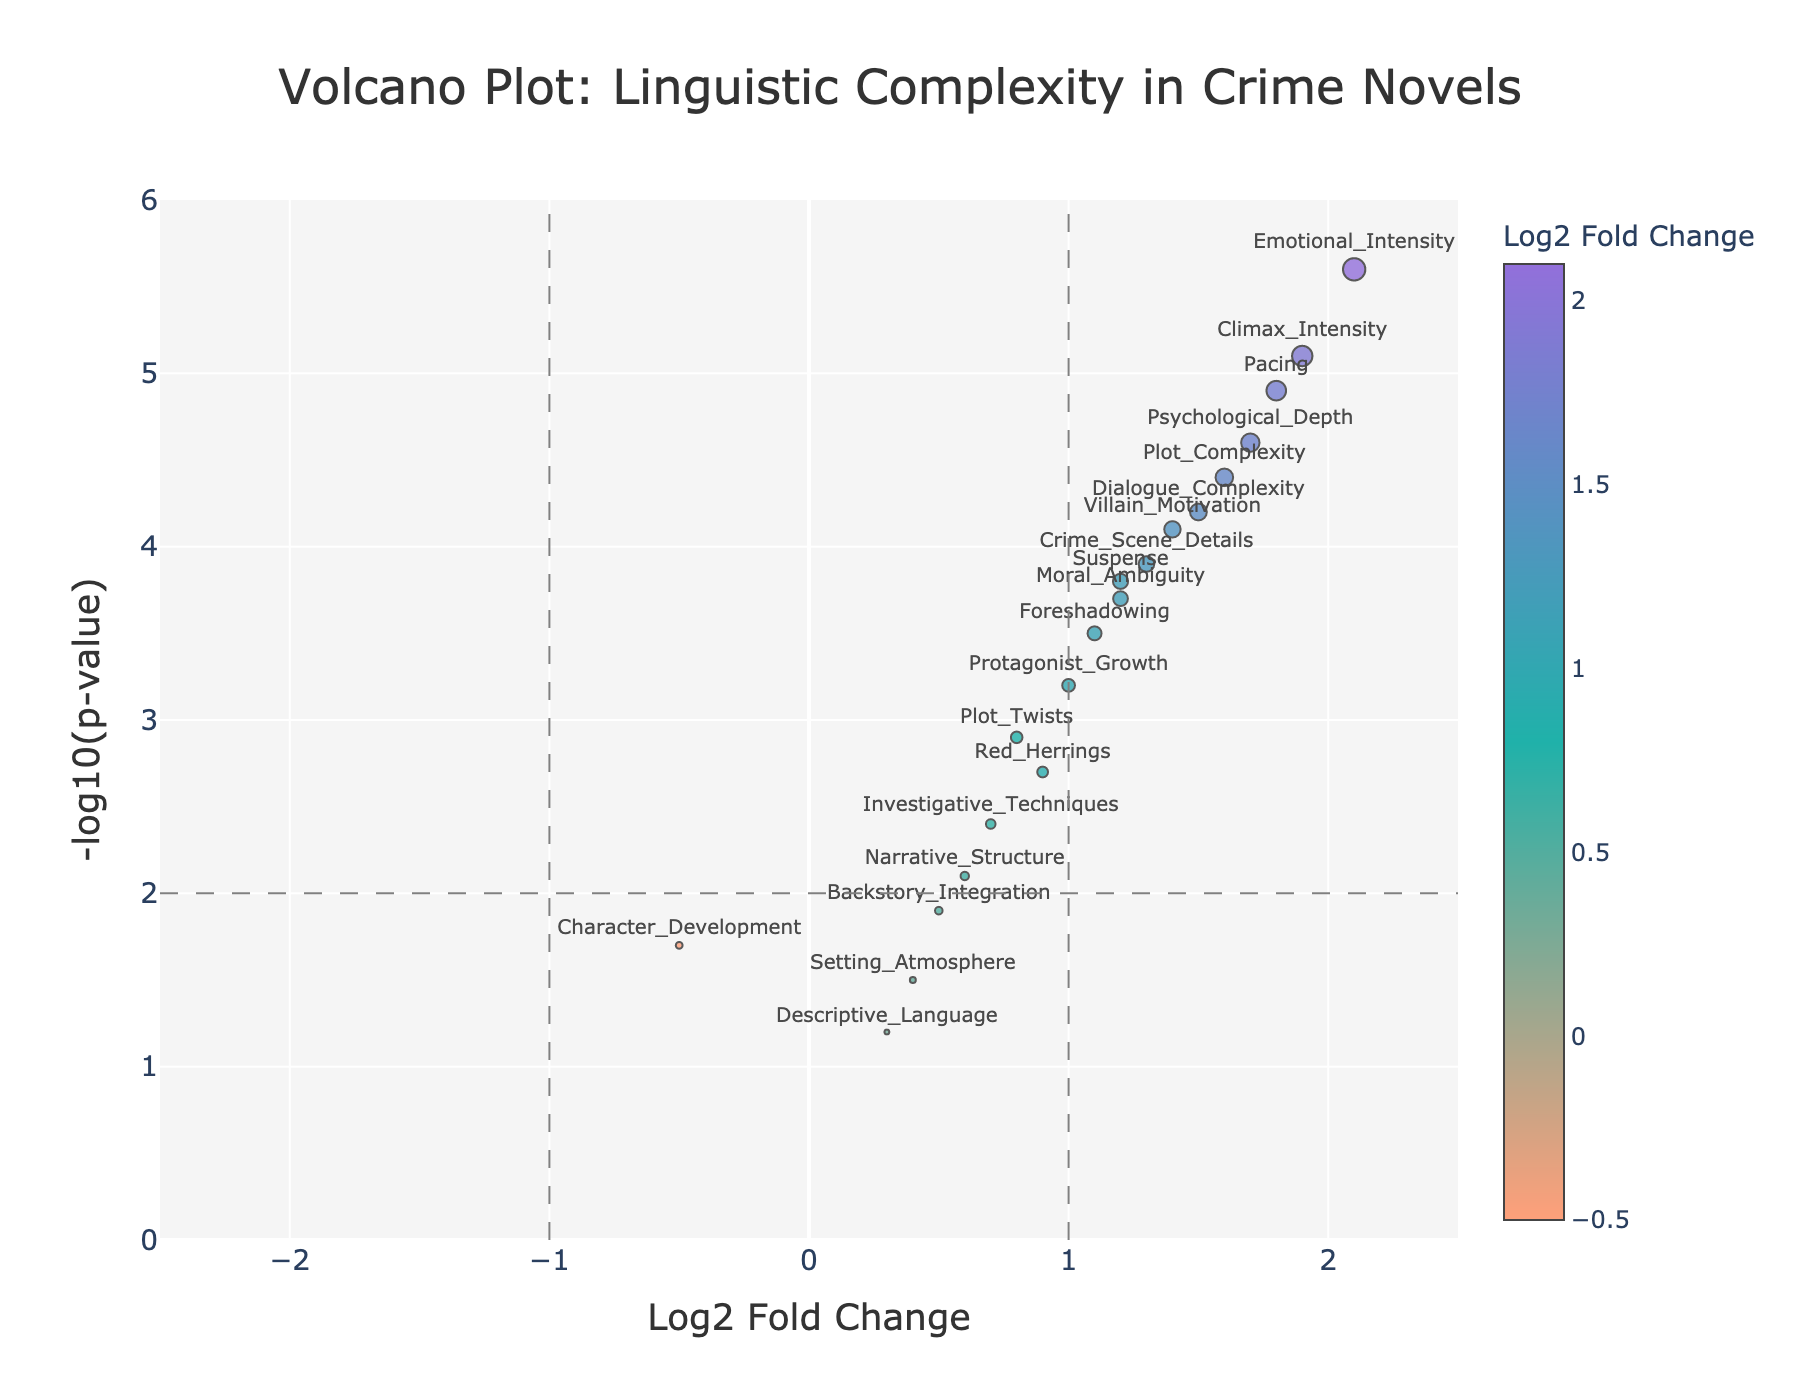What is the title of the plot? The title is usually at the top of the plot. It provides a summary of what the plot is about. In this case, the title is displayed prominently in large font.
Answer: Volcano Plot: Linguistic Complexity in Crime Novels What does the x-axis represent in this plot? The x-axis label is usually mentioned at the bottom of the x-axis in the plot. In this case, it specifies what the horizontal axis measures.
Answer: Log2 Fold Change How many data points in the plot have a Log2 Fold Change greater than 1? To answer this, look for data points whose x-coordinates (Log2 Fold Change) are greater than 1. Count those points.
Answer: 9 Which literary element has the highest negative log p-value? Examine the y-axis (Negative Log P-Value) and find the point that reaches the highest value on that axis. Look at the label for that data point.
Answer: Emotional_Intensity What threshold lines are depicted in the plot? Look for any lines that are different from the data points and might indicate specific threshold values. These are often shown as dashed lines.
Answer: Log2 Fold Change of ±1 and p-value of 0.01 (log10(p-value) of 2) Which literary elements fall above the -log10(p-value) threshold line? Identify and count the points that have a y-coordinate (Negative Log P-Value) above the horizontal dashed line (y=2).
Answer: 10 Which data point represents the "Character_Development" element and where is it located? Look at the hover text or labels near each data point to find "Character_Development" and note its coordinates (x, y).
Answer: (-0.5, 1.7) Compare the Log2 Fold Change values of "Pacing" and "Foreshadowing". Which one is higher? Find the x-coordinates for both "Pacing" and "Foreshadowing", then compare the two values.
Answer: Pacing What color scale is used to represent the Log2 Fold Change? Notice the color gradient or legend on the plot, which usually helps distinguish different values on the x-axis. The colors change based on the Log2 Fold Change values.
Answer: Gradient from light salmon to teal to purple What is the Log2 Fold Change for the data point with the lowest emotional intensity? Look for the data point labeled "Emotional_Intensity" and find its x-coordinate (Log2 Fold Change).
Answer: 2.1 